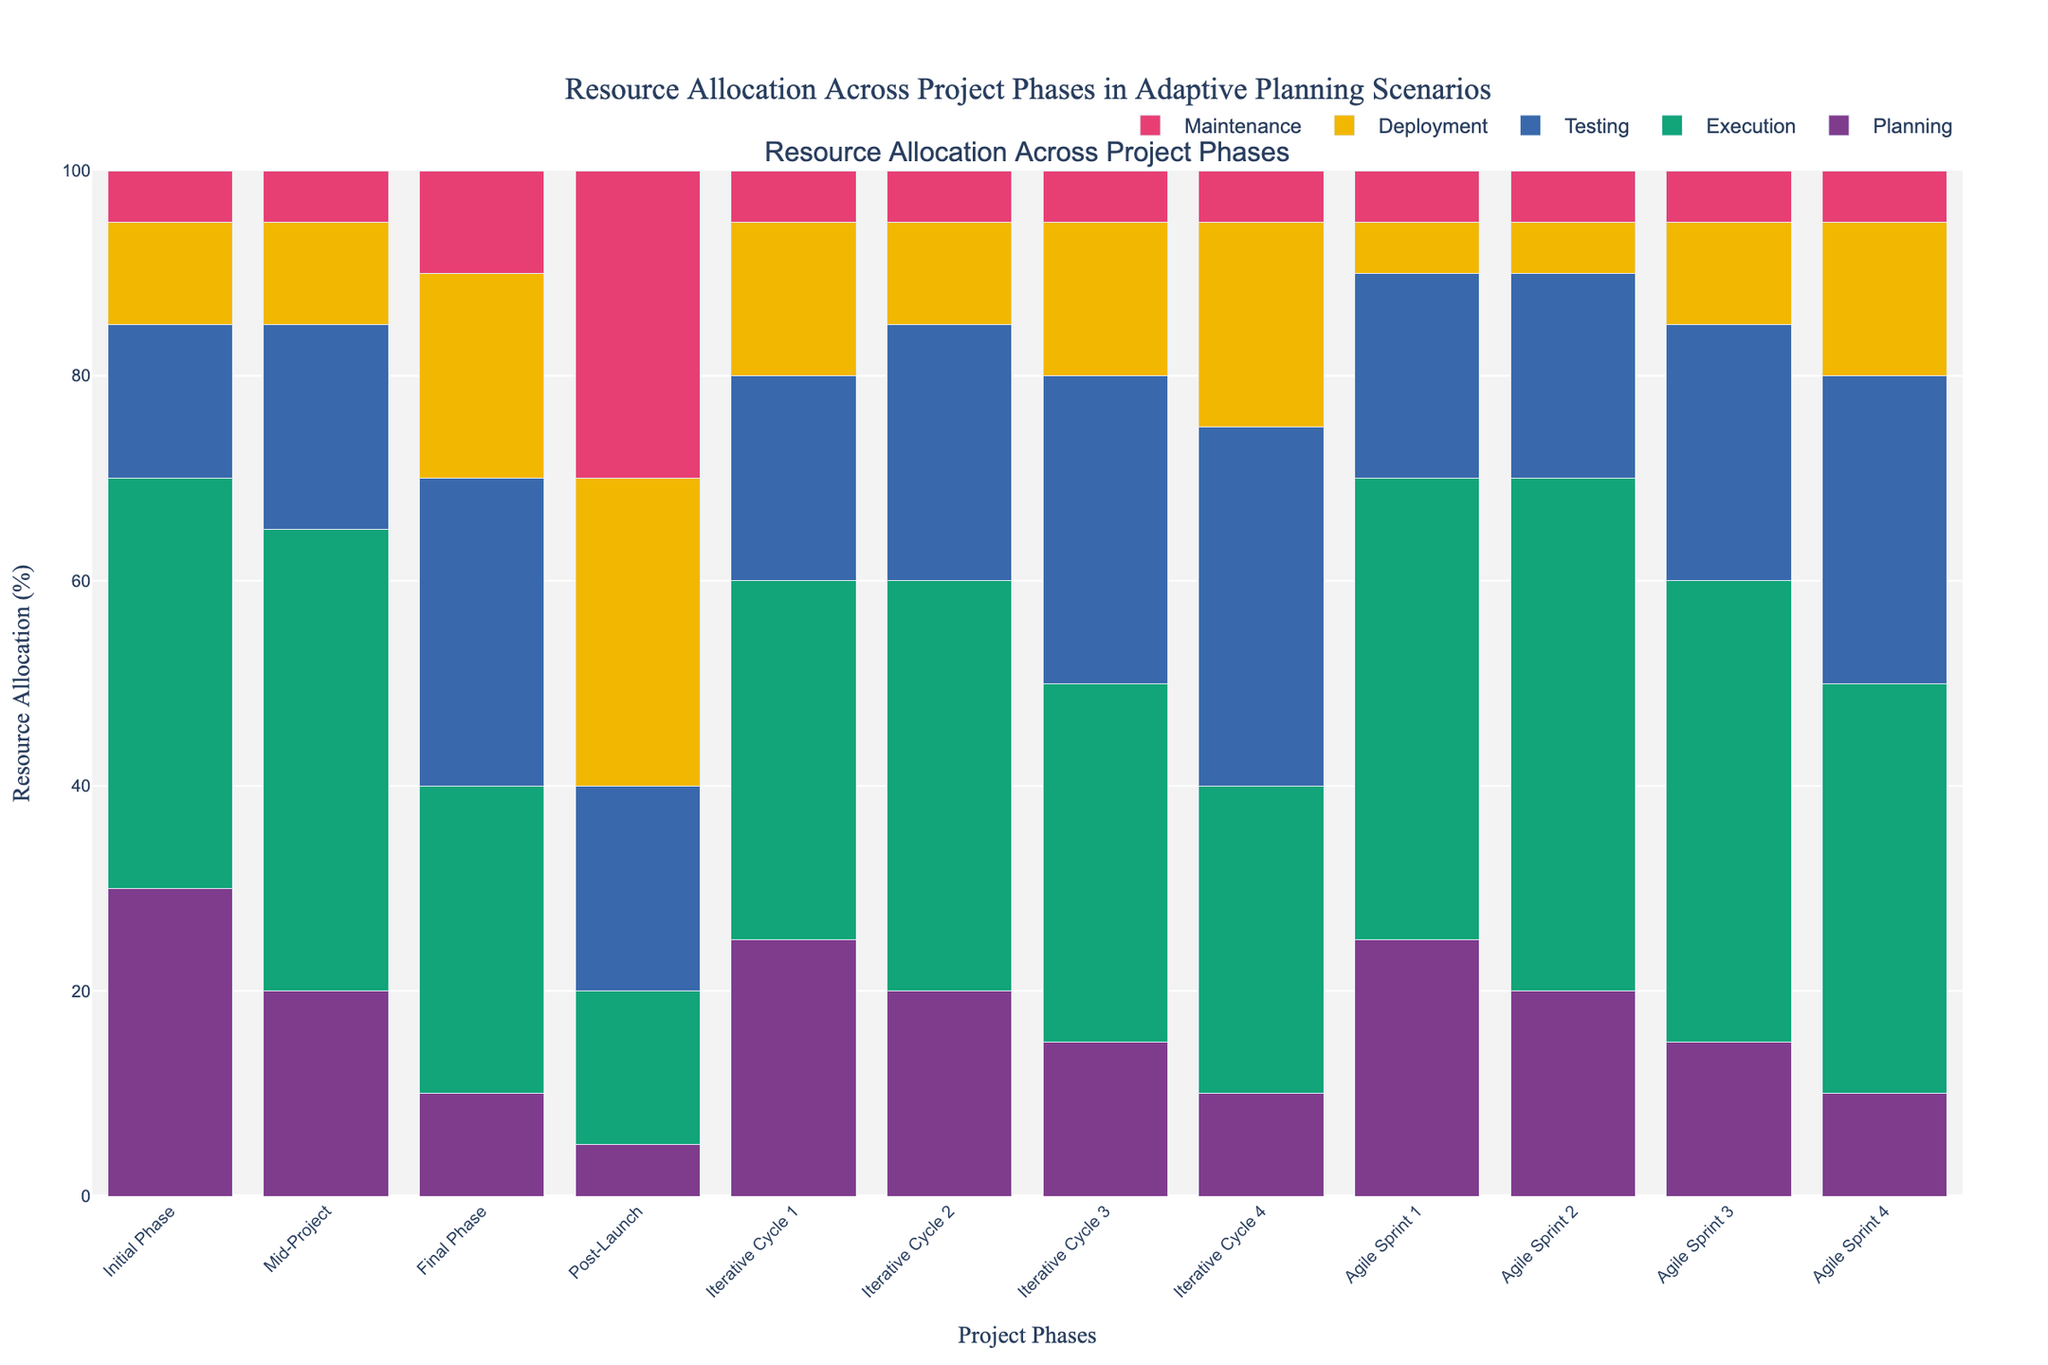Which project phase has the highest resource allocation for the Execution category? By visually inspecting the height of the bars in the Execution category, the phase with the tallest bar represents the highest resource allocation. The Mid-Project phase has the tallest bar for Execution.
Answer: Mid-Project What is the sum of resource allocation percentages for Testing in Iterative Cycle 4 and Agile Sprint 4? Identify the resource allocation values for Testing in both Iterative Cycle 4 (35%) and Agile Sprint 4 (30%) phases and sum them: 35 + 30 = 65.
Answer: 65 Which phase allocates the least resources to Deployment? By examining the height of the Deployment bars, the Initial Phase and Iterative Cycle 2 have the shortest bars at 10%. Thus, the Initial Phase was detected.
Answer: Initial Phase How does the Planning category's resource allocation for Agile Sprints compare to Iterative Cycles? Calculate the average Planning resource allocation for Agile Sprints (Agile Sprint 1: 25%, Agile Sprint 2: 20%, Agile Sprint 3: 15%, Agile Sprint 4: 10%), totaling 25 + 20 + 15 + 10 = 70 and averaging 70/4 = 17.5%. For Iterative Cycles (Iterative Cycle 1: 25%, Iterative Cycle 2: 20%, Iterative Cycle 3: 15%, Iterative Cycle 4: 10%), totaling 25 + 20 + 15 + 10 = 70, averaging 70/4 = 17.5%. Both have an average of 17.5%.
Answer: Equal What is the difference in resource allocation for Maintenance between Post-Launch and Initial Phase? Identify the Maintenance values for Post-Launch (30%) and Initial Phase (5%) and subtract the latter from the former: 30 - 5 = 25.
Answer: 25 